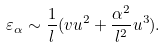<formula> <loc_0><loc_0><loc_500><loc_500>\varepsilon _ { \alpha } \sim \frac { 1 } { l } ( v u ^ { 2 } + \frac { \alpha ^ { 2 } } { l ^ { 2 } } u ^ { 3 } ) .</formula> 